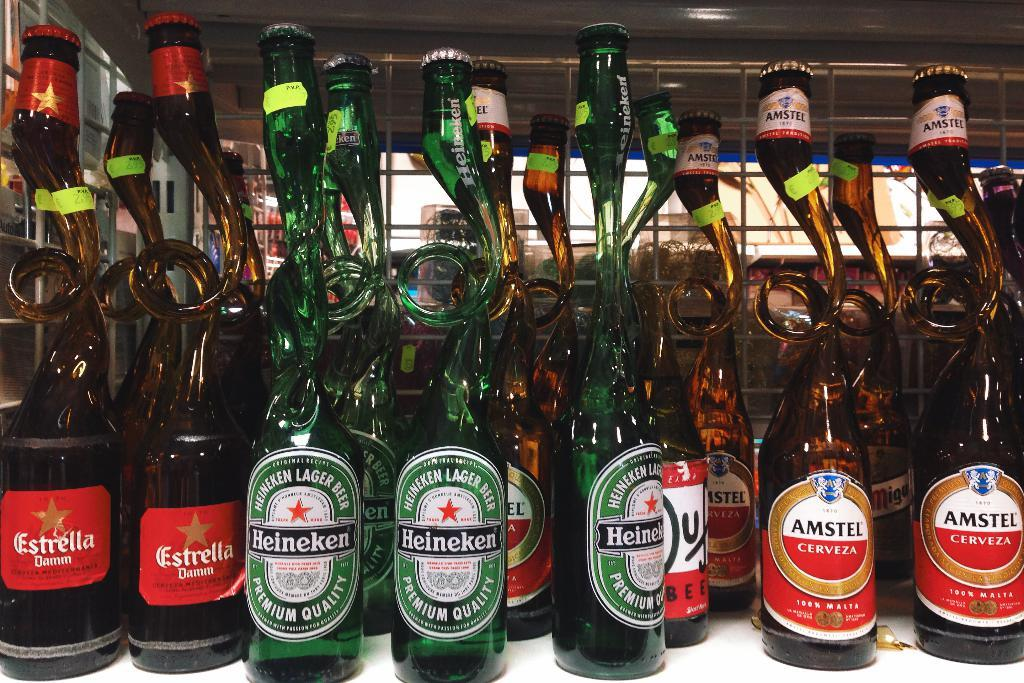<image>
Summarize the visual content of the image. A bunch of bottle of beer from Heineken, Amstel and Estrella 